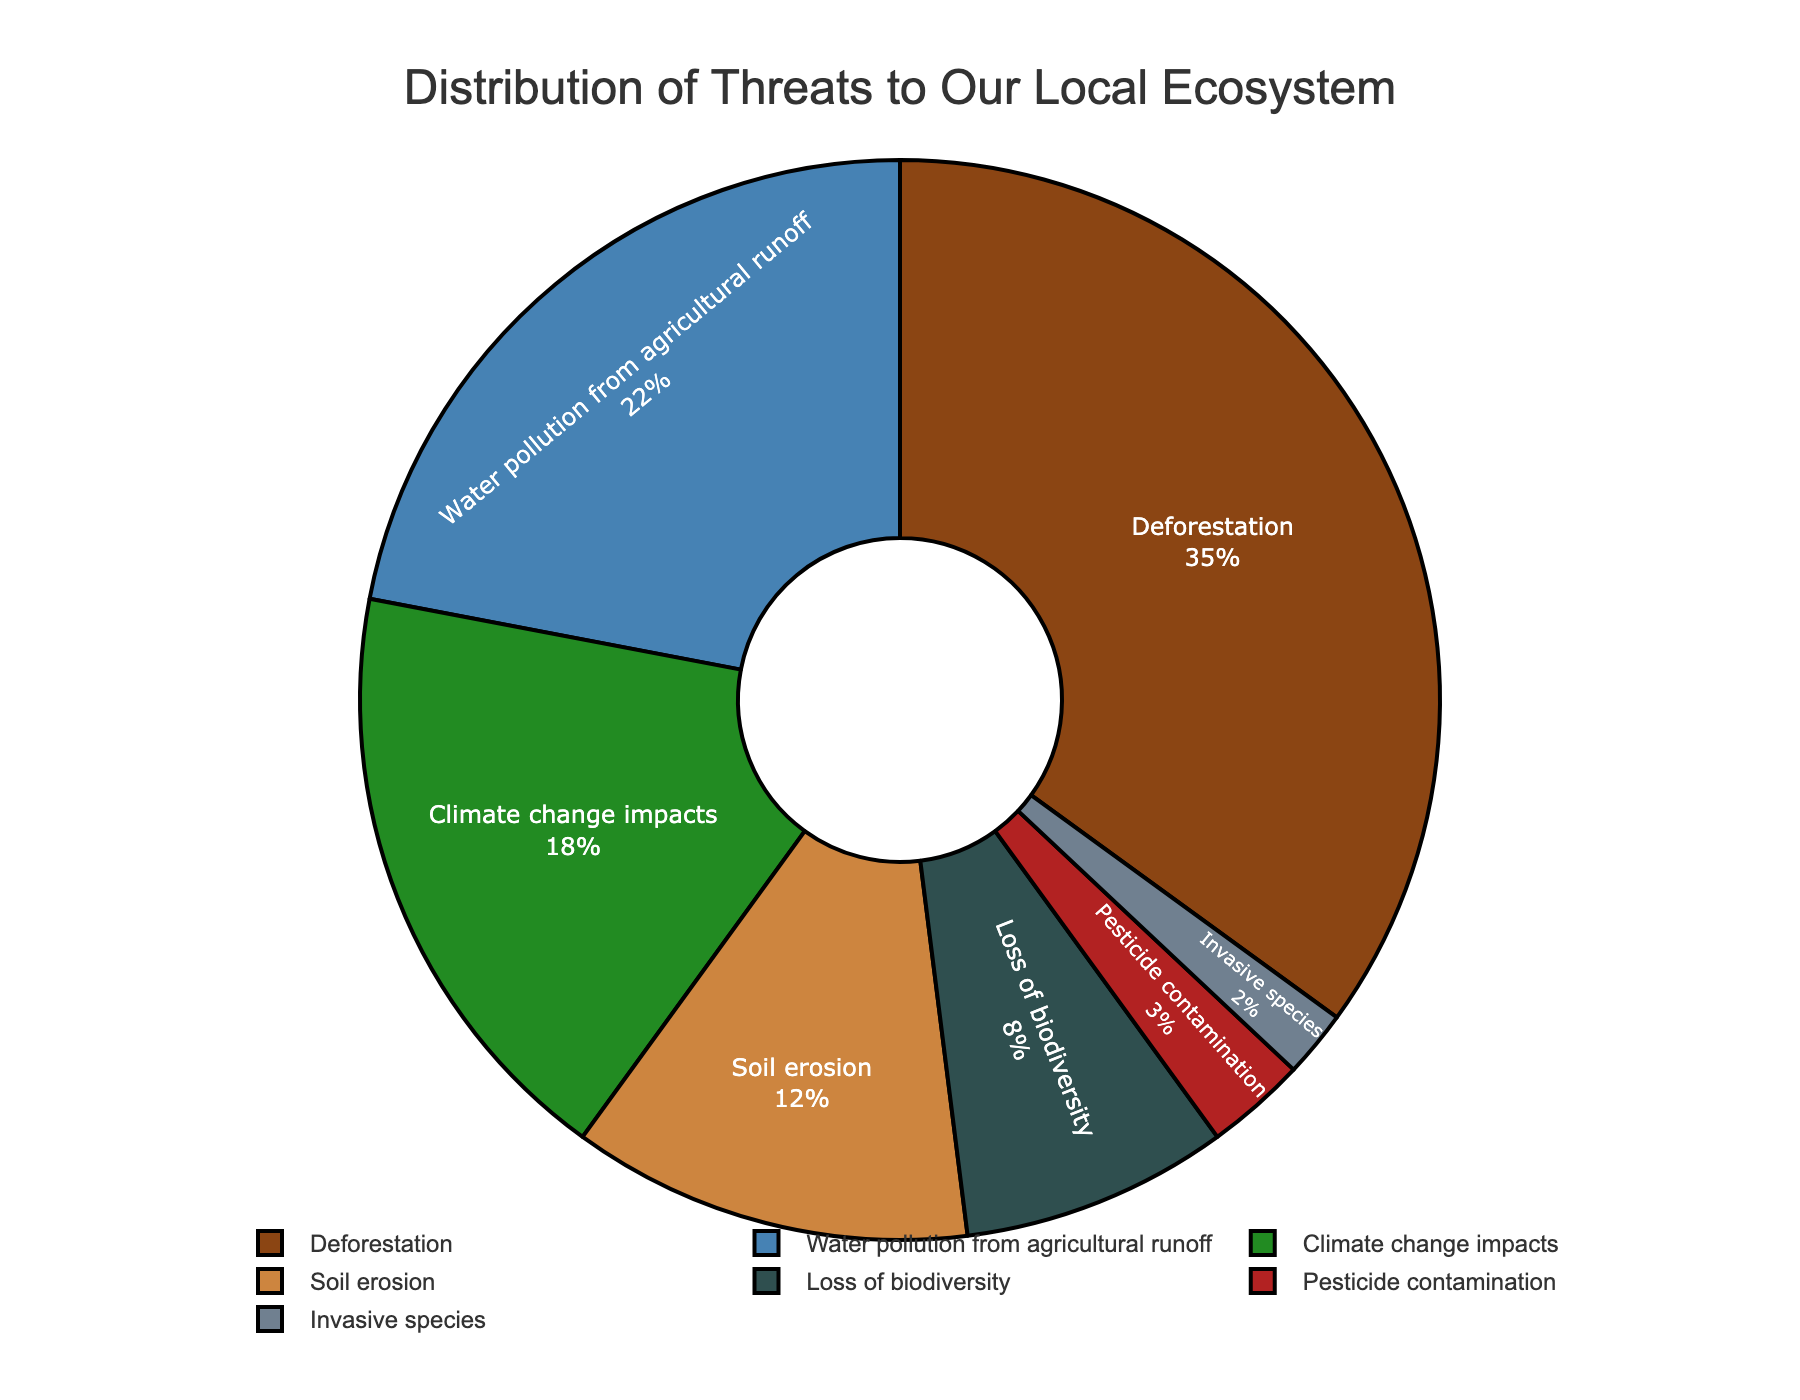What is the most significant threat to the local ecosystem according to the pie chart? The largest portion of the pie chart, which is visually the biggest segment, represents the most significant threat. In this case, deforestation has the highest percentage at 35%.
Answer: Deforestation What percentage of threats do invasive species and pesticide contamination together represent? The percentages of invasive species and pesticide contamination are 2% and 3%, respectively. Summing these values gives us the total percentage. So, 2% + 3% = 5%.
Answer: 5% How does the percentage of water pollution from agricultural runoff compare to the sum of the percentages of soil erosion and loss of biodiversity? Water pollution from agricultural runoff is 22%. Soil erosion is 12% and loss of biodiversity is 8%. Summing soil erosion and loss of biodiversity gives us 12% + 8% = 20%. Comparing 22% and 20% shows that water pollution from agricultural runoff is greater.
Answer: Greater Which threat occupies the smallest portion of the pie chart? The smallest portion of the pie chart represents the threat with the lowest percentage. In this case, invasive species have the smallest percentage at 2%.
Answer: Invasive species What is the combined percentage of deforestation and climate change impacts? The percentages of deforestation and climate change impacts are 35% and 18%, respectively. Adding these values together gives us 35% + 18% = 53%.
Answer: 53% What is the difference in percentage points between the highest and lowest threats? The highest threat is deforestation at 35%, and the lowest threat is invasive species at 2%. The difference is calculated as 35% - 2% = 33%.
Answer: 33% How do the colors assigned to soil erosion and loss of biodiversity compare visually? Soil erosion is represented by a visually dark brown color, while loss of biodiversity has a visually dark green shade. These colors are distinct, making them easily differentiable.
Answer: Distinct If the threats with percentages below 5% are combined, what percentage of the total do they represent? The threats below 5% are pesticide contamination (3%) and invasive species (2%). The combined percentage is 3% + 2% = 5%.
Answer: 5% What percentage of threats is attributed to climate change impacts relative to deforestation? Climate change impacts contribute 18%, whereas deforestation contributes 35%. To find the relative percentage, divide 18 by 35 and multiply by 100. (18 / 35) * 100 ≈ 51.43%.
Answer: Approximately 51.43% Is there a threat category that has an equal or very close percentage to the combination of soil erosion and loss of biodiversity? Soil erosion is 12% and loss of biodiversity is 8%. Combined, they total 12% + 8% = 20%. Water pollution from agricultural runoff is close at 22%, which is slightly larger but relatively close.
Answer: Water pollution from agricultural runoff 